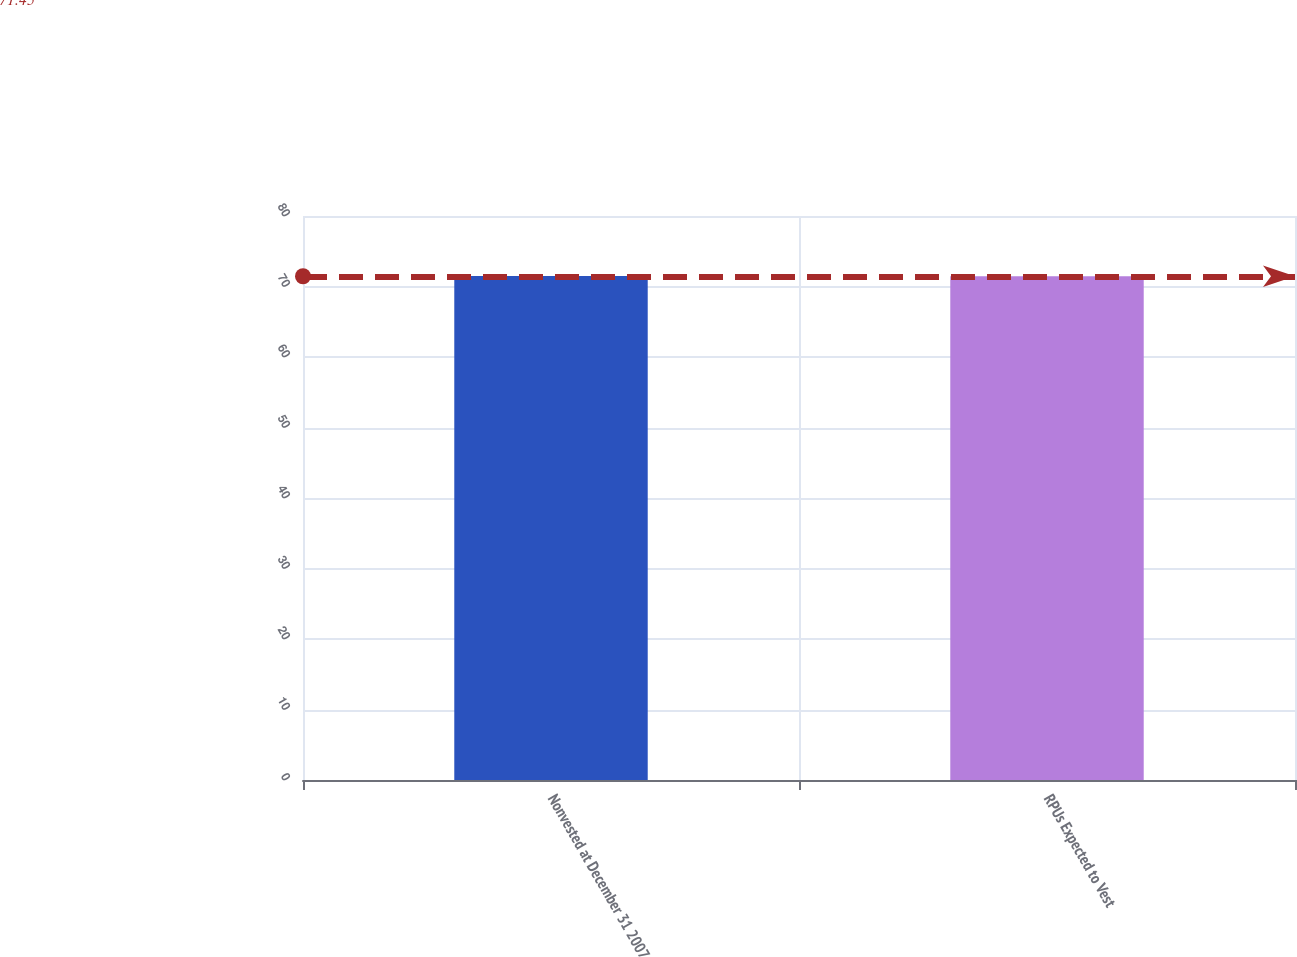<chart> <loc_0><loc_0><loc_500><loc_500><bar_chart><fcel>Nonvested at December 31 2007<fcel>RPUs Expected to Vest<nl><fcel>71.5<fcel>71.44<nl></chart> 